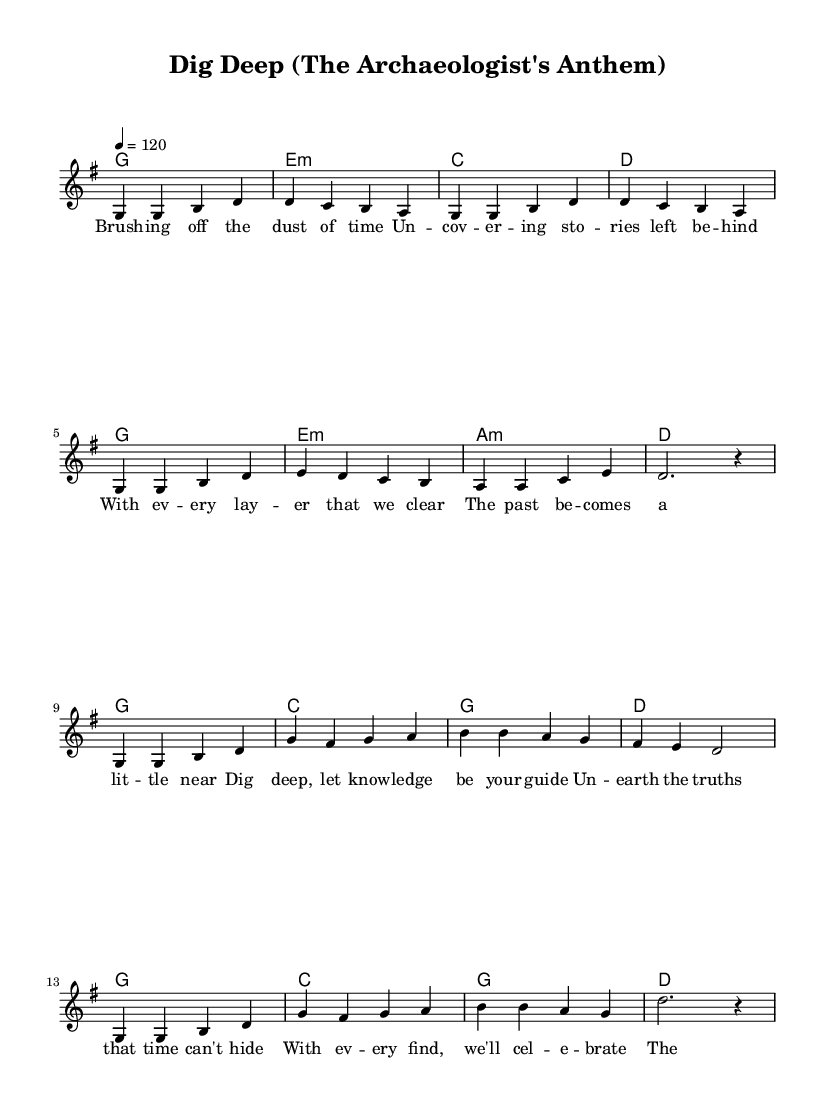What is the key signature of this music? The key signature shown at the beginning of the piece indicates that it is in G major, which contains an F sharp.
Answer: G major What is the time signature of this music? The time signature, indicated by the notation at the beginning of the piece, is 4/4, meaning there are four beats in each measure.
Answer: 4/4 What is the tempo of this music? The tempo marking indicates that the music should be played at a speed of 120 beats per minute.
Answer: 120 How many measures are there in the verse? By counting the groups of notes notated, there are a total of 8 measures in the verse section.
Answer: 8 What is the first chord of the chorus? The first chord of the chorus is indicated as G major, which is represented by the note G in the chord section.
Answer: G Why is the phrase "unearth the truths that time can't hide" significant in the context of academic achievement? This phrase emphasizes the value of scholarly work in uncovering historical truths and knowledge, which resonates with the theme of academic pursuit and discovery. The deeper meaning links to the role of archaeologists in revealing hidden knowledge through their research.
Answer: Scholarly significance What style does this music reflect within the Pop genre? The music features an uplifting and anthemic quality typical of Pop anthems that celebrate achievement, characterized by a catchy melody and repetitive, motivational lyrics. This focus on celebration and aspiration is especially common in Pop music.
Answer: Uplifting anthem 